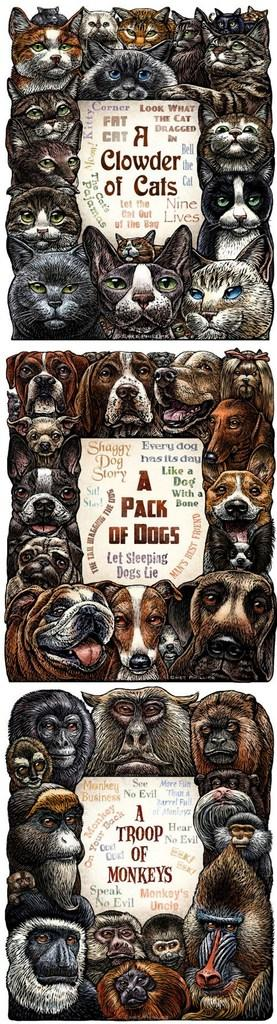What is the nature of the image? The image appears to be edited. What types of creatures are featured in the image? There are faces of different animals in the image. What other objects can be seen in the image? There are papers with letters on them in the image. What type of scent can be detected from the jam in the image? There is no jam present in the image, so it is not possible to determine any scent. 